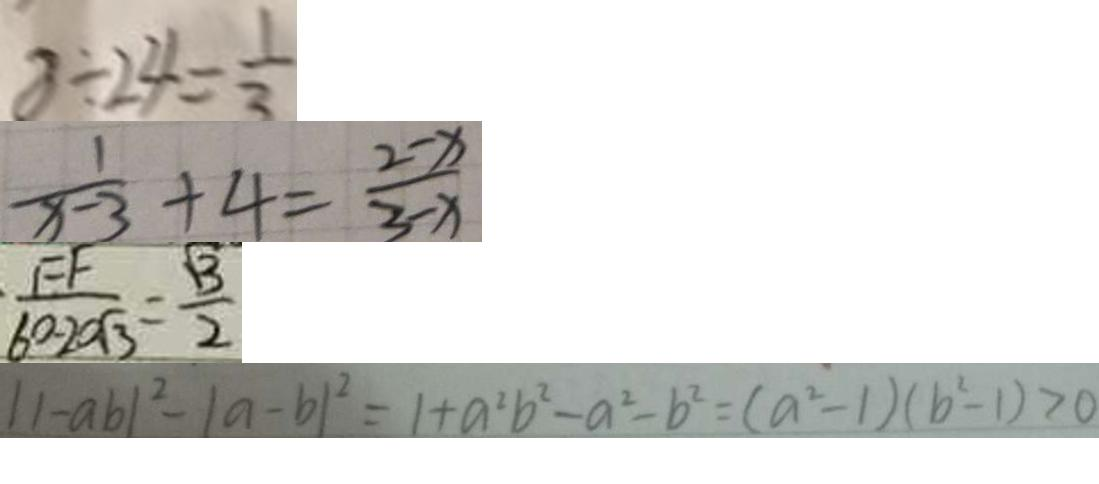<formula> <loc_0><loc_0><loc_500><loc_500>8 \div 2 4 = \frac { 1 } { 3 } 
 \frac { 1 } { x - 3 } + 4 = \frac { 2 - x } { 3 - x } 
 \frac { F F } { 6 0 - 2 0 \sqrt { 3 } } = \frac { \sqrt { 3 } } { 2 } 
 \vert \vert - a b \vert ^ { 2 } - \vert a - b \vert ^ { 2 } = 1 + a ^ { 2 } b ^ { 2 } - a ^ { 2 } - b ^ { 2 } = ( a ^ { 2 } - 1 ) ( b ^ { 2 } - 1 ) > 0</formula> 